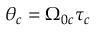Convert formula to latex. <formula><loc_0><loc_0><loc_500><loc_500>\theta _ { c } = \Omega _ { 0 c } \tau _ { c }</formula> 